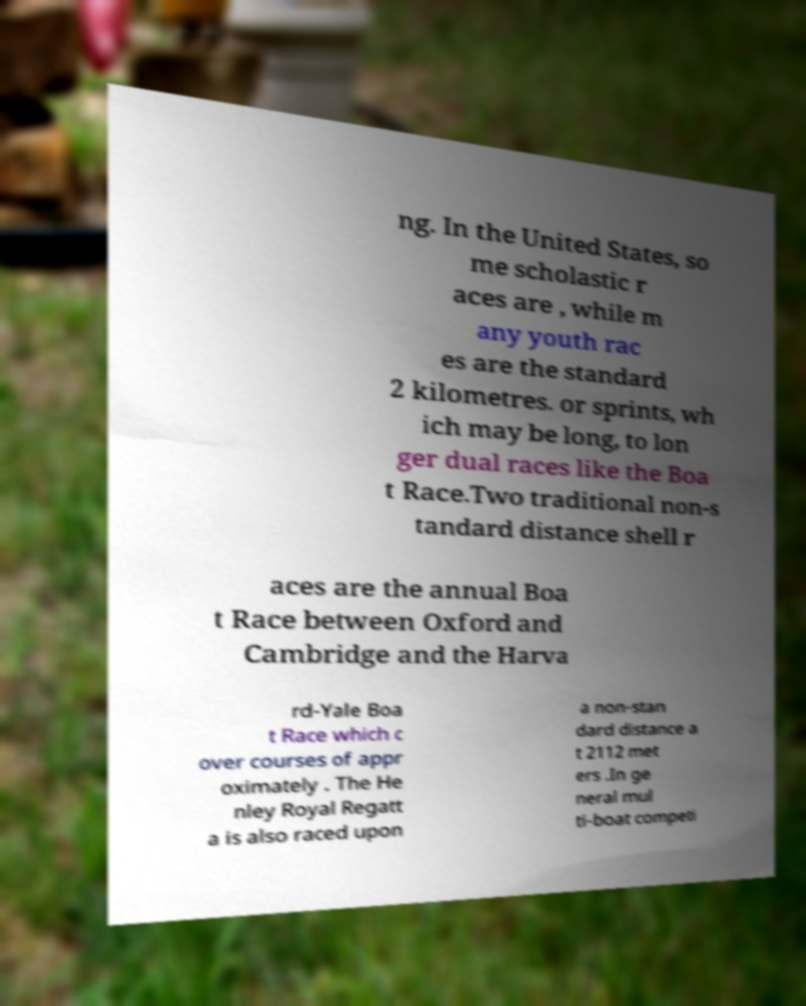Please identify and transcribe the text found in this image. ng. In the United States, so me scholastic r aces are , while m any youth rac es are the standard 2 kilometres. or sprints, wh ich may be long, to lon ger dual races like the Boa t Race.Two traditional non-s tandard distance shell r aces are the annual Boa t Race between Oxford and Cambridge and the Harva rd-Yale Boa t Race which c over courses of appr oximately . The He nley Royal Regatt a is also raced upon a non-stan dard distance a t 2112 met ers .In ge neral mul ti-boat competi 